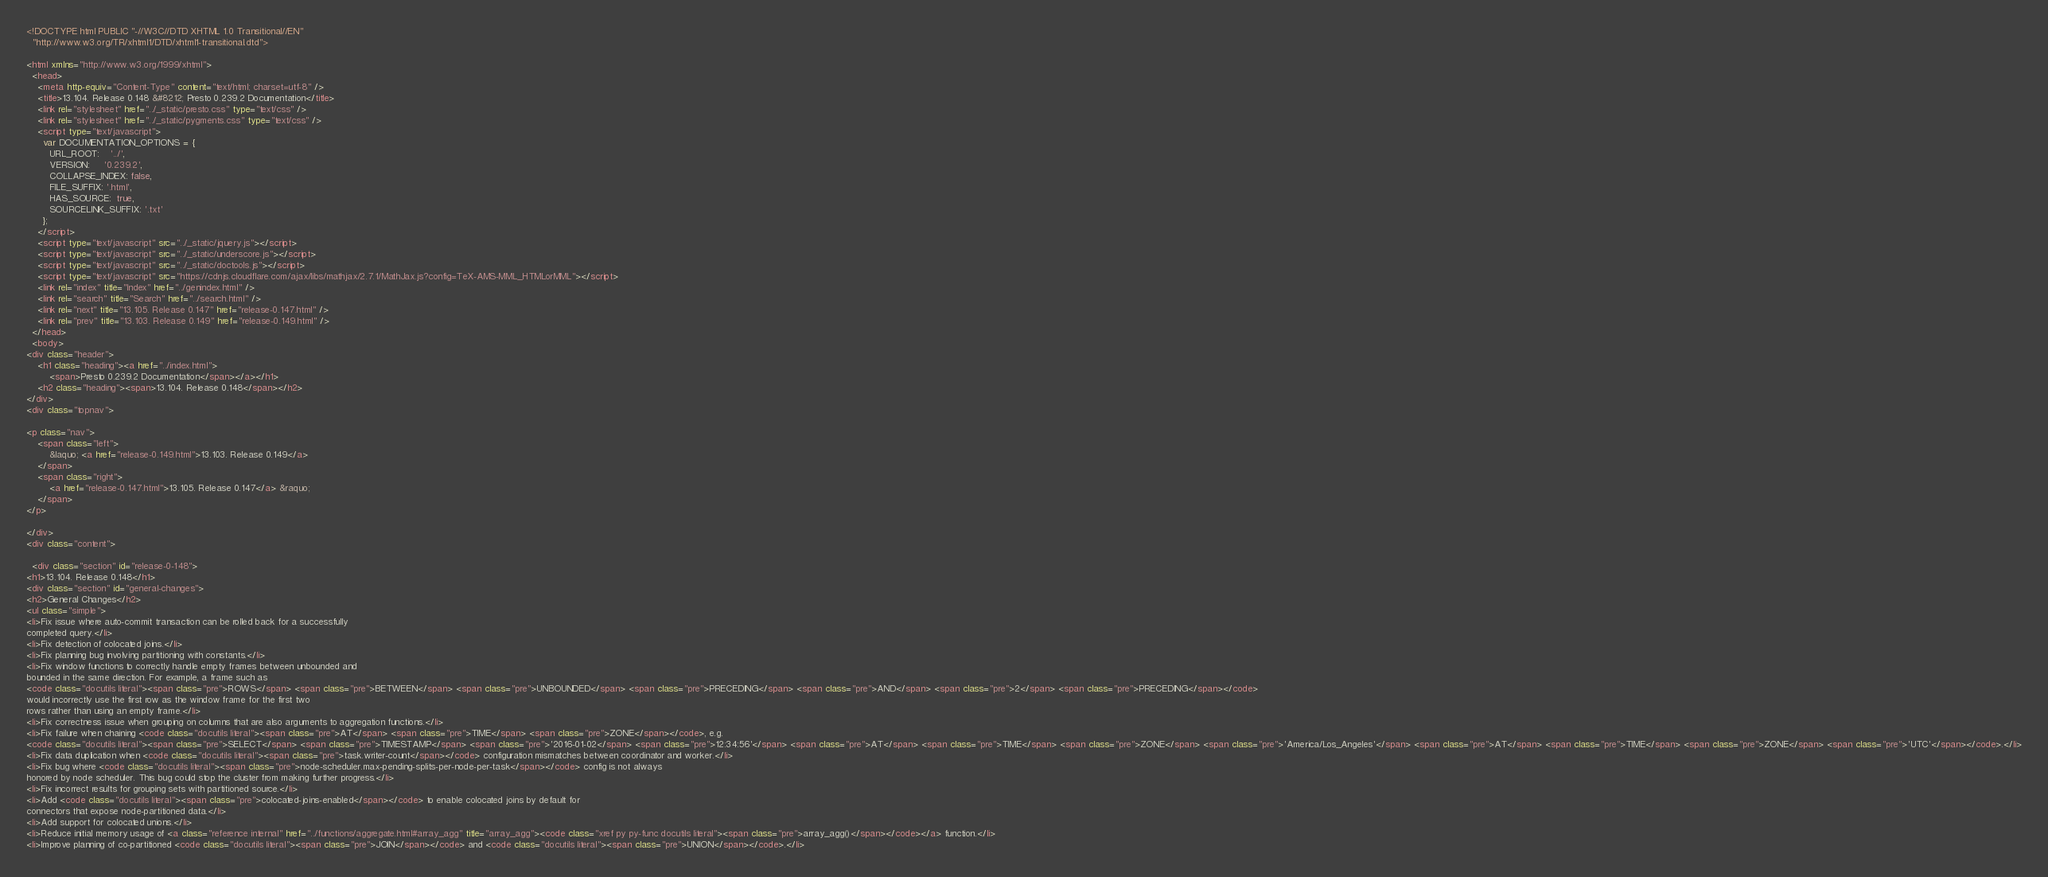Convert code to text. <code><loc_0><loc_0><loc_500><loc_500><_HTML_>
<!DOCTYPE html PUBLIC "-//W3C//DTD XHTML 1.0 Transitional//EN"
  "http://www.w3.org/TR/xhtml1/DTD/xhtml1-transitional.dtd">

<html xmlns="http://www.w3.org/1999/xhtml">
  <head>
    <meta http-equiv="Content-Type" content="text/html; charset=utf-8" />
    <title>13.104. Release 0.148 &#8212; Presto 0.239.2 Documentation</title>
    <link rel="stylesheet" href="../_static/presto.css" type="text/css" />
    <link rel="stylesheet" href="../_static/pygments.css" type="text/css" />
    <script type="text/javascript">
      var DOCUMENTATION_OPTIONS = {
        URL_ROOT:    '../',
        VERSION:     '0.239.2',
        COLLAPSE_INDEX: false,
        FILE_SUFFIX: '.html',
        HAS_SOURCE:  true,
        SOURCELINK_SUFFIX: '.txt'
      };
    </script>
    <script type="text/javascript" src="../_static/jquery.js"></script>
    <script type="text/javascript" src="../_static/underscore.js"></script>
    <script type="text/javascript" src="../_static/doctools.js"></script>
    <script type="text/javascript" src="https://cdnjs.cloudflare.com/ajax/libs/mathjax/2.7.1/MathJax.js?config=TeX-AMS-MML_HTMLorMML"></script>
    <link rel="index" title="Index" href="../genindex.html" />
    <link rel="search" title="Search" href="../search.html" />
    <link rel="next" title="13.105. Release 0.147" href="release-0.147.html" />
    <link rel="prev" title="13.103. Release 0.149" href="release-0.149.html" /> 
  </head>
  <body>
<div class="header">
    <h1 class="heading"><a href="../index.html">
        <span>Presto 0.239.2 Documentation</span></a></h1>
    <h2 class="heading"><span>13.104. Release 0.148</span></h2>
</div>
<div class="topnav">
    
<p class="nav">
    <span class="left">
        &laquo; <a href="release-0.149.html">13.103. Release 0.149</a>
    </span>
    <span class="right">
        <a href="release-0.147.html">13.105. Release 0.147</a> &raquo;
    </span>
</p>

</div>
<div class="content">
    
  <div class="section" id="release-0-148">
<h1>13.104. Release 0.148</h1>
<div class="section" id="general-changes">
<h2>General Changes</h2>
<ul class="simple">
<li>Fix issue where auto-commit transaction can be rolled back for a successfully
completed query.</li>
<li>Fix detection of colocated joins.</li>
<li>Fix planning bug involving partitioning with constants.</li>
<li>Fix window functions to correctly handle empty frames between unbounded and
bounded in the same direction. For example, a frame such as
<code class="docutils literal"><span class="pre">ROWS</span> <span class="pre">BETWEEN</span> <span class="pre">UNBOUNDED</span> <span class="pre">PRECEDING</span> <span class="pre">AND</span> <span class="pre">2</span> <span class="pre">PRECEDING</span></code>
would incorrectly use the first row as the window frame for the first two
rows rather than using an empty frame.</li>
<li>Fix correctness issue when grouping on columns that are also arguments to aggregation functions.</li>
<li>Fix failure when chaining <code class="docutils literal"><span class="pre">AT</span> <span class="pre">TIME</span> <span class="pre">ZONE</span></code>, e.g.
<code class="docutils literal"><span class="pre">SELECT</span> <span class="pre">TIMESTAMP</span> <span class="pre">'2016-01-02</span> <span class="pre">12:34:56'</span> <span class="pre">AT</span> <span class="pre">TIME</span> <span class="pre">ZONE</span> <span class="pre">'America/Los_Angeles'</span> <span class="pre">AT</span> <span class="pre">TIME</span> <span class="pre">ZONE</span> <span class="pre">'UTC'</span></code>.</li>
<li>Fix data duplication when <code class="docutils literal"><span class="pre">task.writer-count</span></code> configuration mismatches between coordinator and worker.</li>
<li>Fix bug where <code class="docutils literal"><span class="pre">node-scheduler.max-pending-splits-per-node-per-task</span></code> config is not always
honored by node scheduler. This bug could stop the cluster from making further progress.</li>
<li>Fix incorrect results for grouping sets with partitioned source.</li>
<li>Add <code class="docutils literal"><span class="pre">colocated-joins-enabled</span></code> to enable colocated joins by default for
connectors that expose node-partitioned data.</li>
<li>Add support for colocated unions.</li>
<li>Reduce initial memory usage of <a class="reference internal" href="../functions/aggregate.html#array_agg" title="array_agg"><code class="xref py py-func docutils literal"><span class="pre">array_agg()</span></code></a> function.</li>
<li>Improve planning of co-partitioned <code class="docutils literal"><span class="pre">JOIN</span></code> and <code class="docutils literal"><span class="pre">UNION</span></code>.</li></code> 